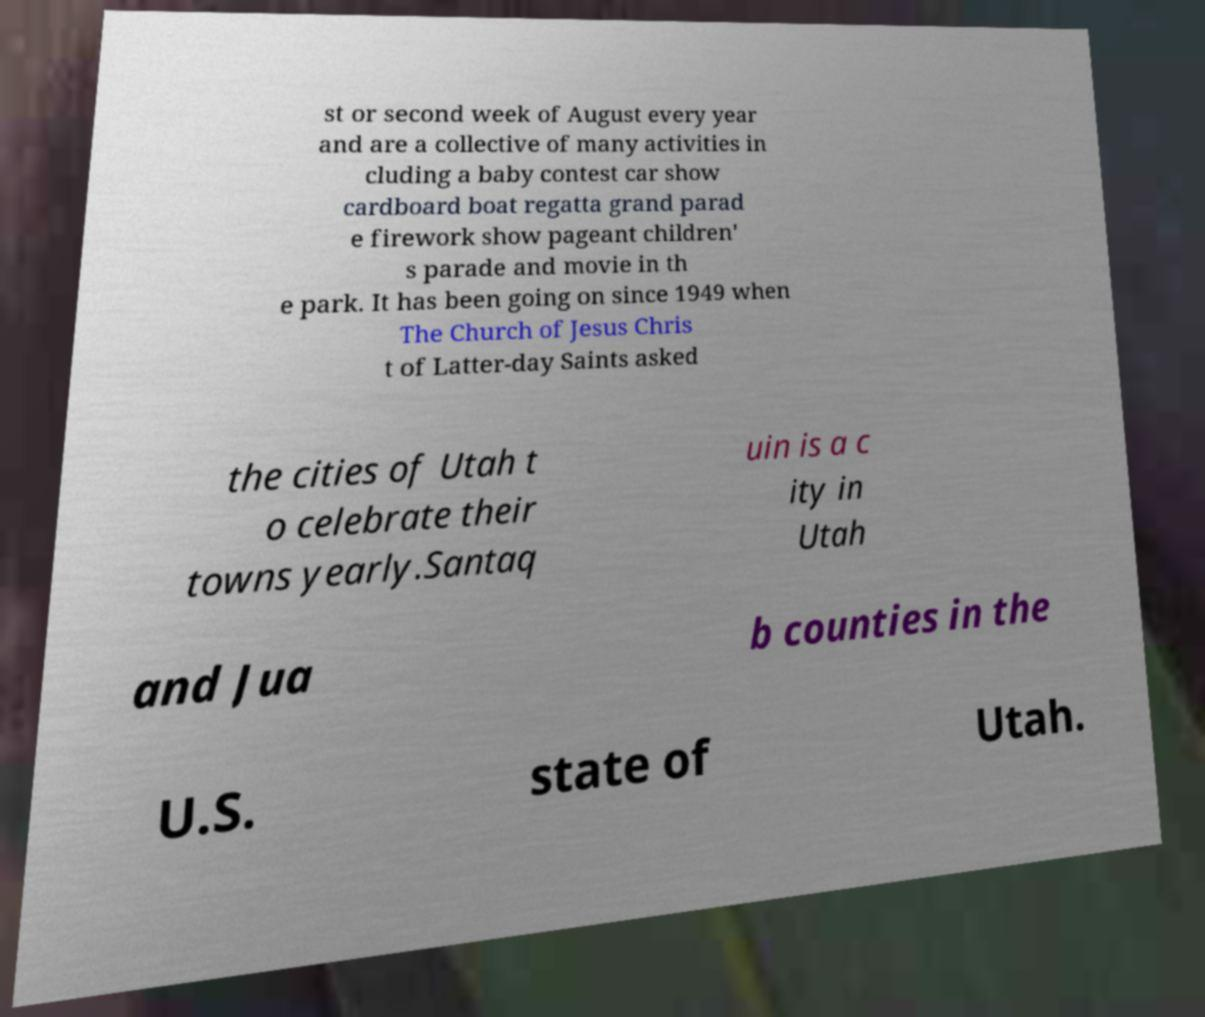I need the written content from this picture converted into text. Can you do that? st or second week of August every year and are a collective of many activities in cluding a baby contest car show cardboard boat regatta grand parad e firework show pageant children' s parade and movie in th e park. It has been going on since 1949 when The Church of Jesus Chris t of Latter-day Saints asked the cities of Utah t o celebrate their towns yearly.Santaq uin is a c ity in Utah and Jua b counties in the U.S. state of Utah. 